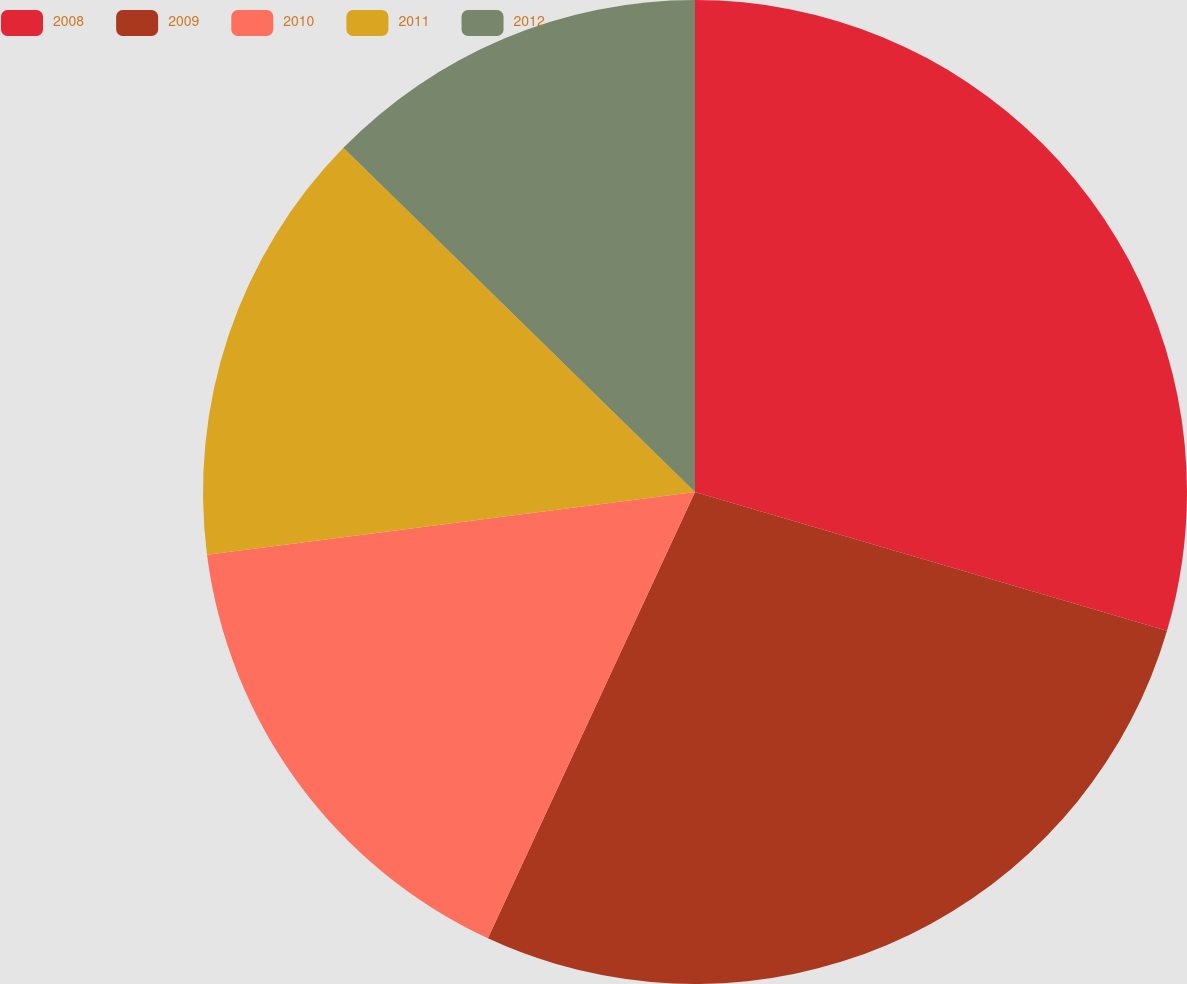Convert chart to OTSL. <chart><loc_0><loc_0><loc_500><loc_500><pie_chart><fcel>2008<fcel>2009<fcel>2010<fcel>2011<fcel>2012<nl><fcel>29.55%<fcel>27.36%<fcel>16.05%<fcel>14.36%<fcel>12.67%<nl></chart> 